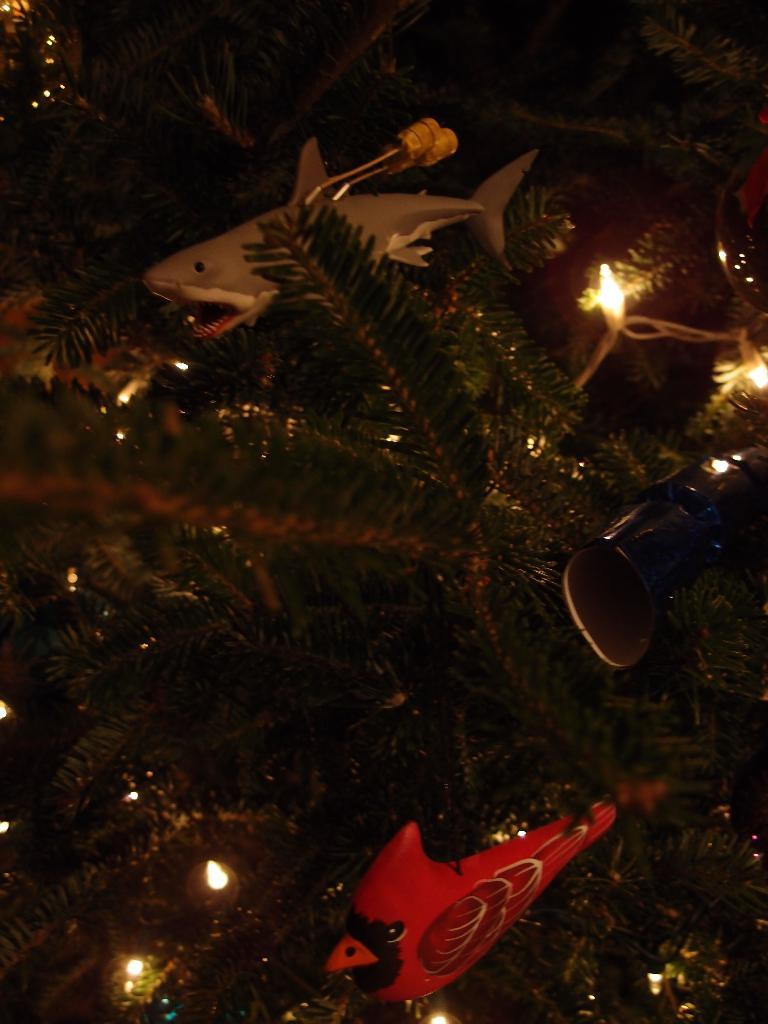What is the main object in the image that resembles a Christmas tree? There is an object that looks like a Christmas tree in the image. What feature is present on the Christmas tree? The Christmas tree has lights. Are there any other objects related to the Christmas tree in the image? Yes, there are other objects associated with the Christmas tree. What time of day is it in the image, as indicated by the presence of a bubble? There is no bubble present in the image, so we cannot determine the time of day based on that. 